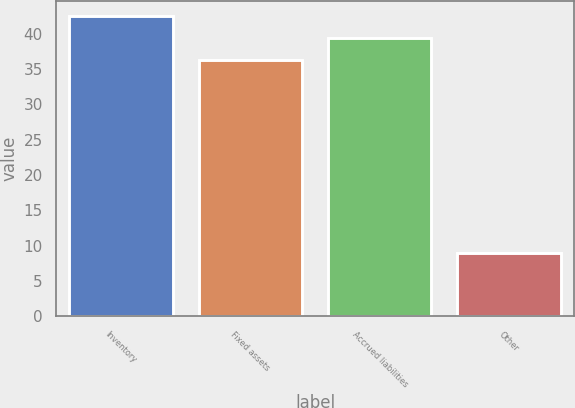<chart> <loc_0><loc_0><loc_500><loc_500><bar_chart><fcel>Inventory<fcel>Fixed assets<fcel>Accrued liabilities<fcel>Other<nl><fcel>42.54<fcel>36.3<fcel>39.42<fcel>8.9<nl></chart> 